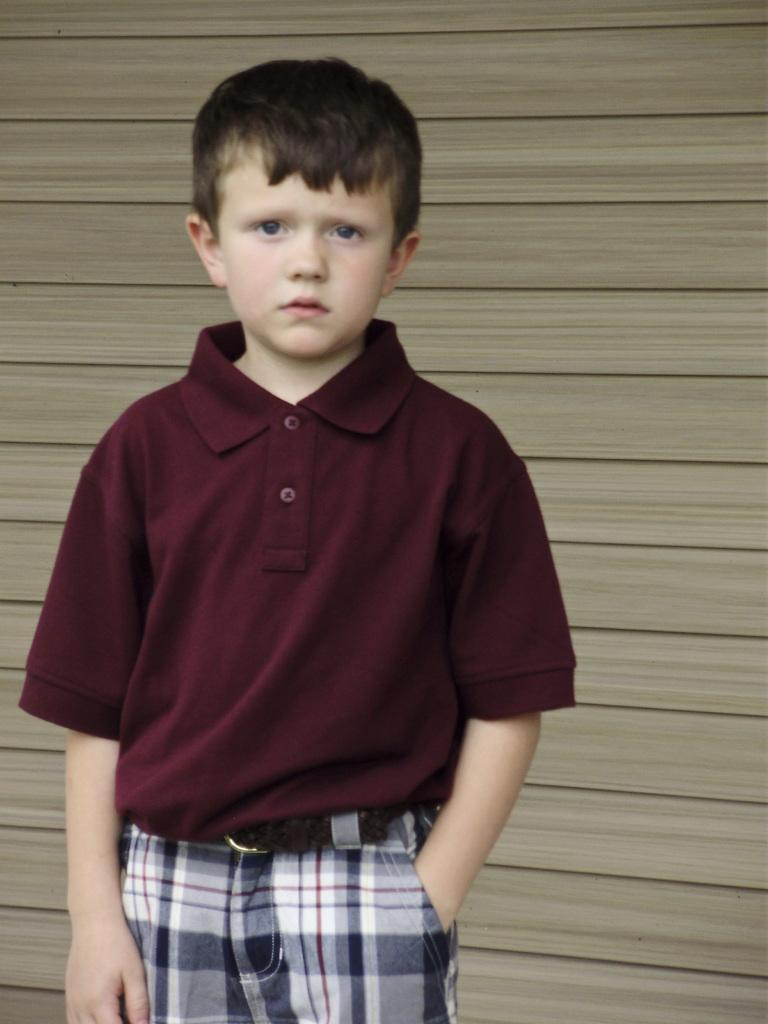What is the main subject of the image? There is a boy in the image. What is the boy doing in the image? The boy is staring at the camera. How many geese are flying in the image? There are no geese present in the image; it features only a boy staring at the camera. What type of blood is visible on the boy's shirt in the image? There is no blood visible on the boy's shirt in the image. 